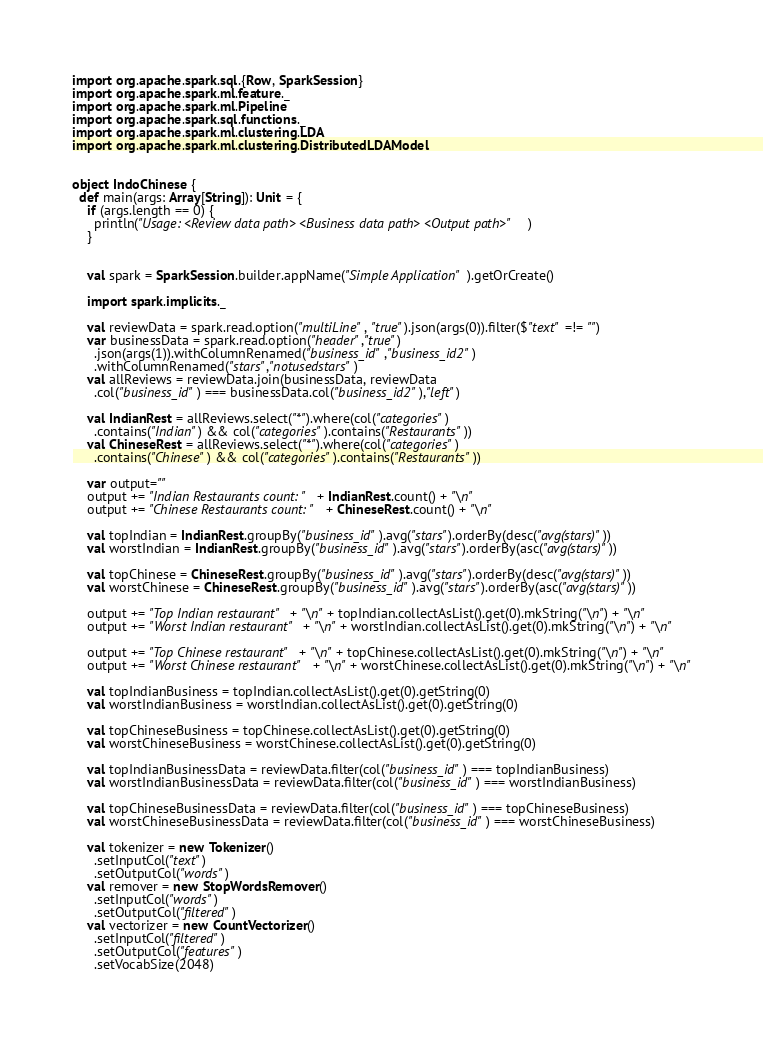Convert code to text. <code><loc_0><loc_0><loc_500><loc_500><_Scala_>import org.apache.spark.sql.{Row, SparkSession}
import org.apache.spark.ml.feature._
import org.apache.spark.ml.Pipeline
import org.apache.spark.sql.functions._
import org.apache.spark.ml.clustering.LDA
import org.apache.spark.ml.clustering.DistributedLDAModel


object IndoChinese {
  def main(args: Array[String]): Unit = {
    if (args.length == 0) {
      println("Usage: <Review data path> <Business data path> <Output path>")
    }


    val spark = SparkSession.builder.appName("Simple Application").getOrCreate()

    import spark.implicits._

    val reviewData = spark.read.option("multiLine", "true").json(args(0)).filter($"text" =!= "")
    var businessData = spark.read.option("header","true")
      .json(args(1)).withColumnRenamed("business_id","business_id2")
      .withColumnRenamed("stars","notusedstars")
    val allReviews = reviewData.join(businessData, reviewData
      .col("business_id") === businessData.col("business_id2"),"left")

    val IndianRest = allReviews.select("*").where(col("categories")
      .contains("Indian") && col("categories").contains("Restaurants"))
    val ChineseRest = allReviews.select("*").where(col("categories")
      .contains("Chinese") && col("categories").contains("Restaurants"))

    var output=""
    output += "Indian Restaurants count: " + IndianRest.count() + "\n"
    output += "Chinese Restaurants count: " + ChineseRest.count() + "\n"

    val topIndian = IndianRest.groupBy("business_id").avg("stars").orderBy(desc("avg(stars)"))
    val worstIndian = IndianRest.groupBy("business_id").avg("stars").orderBy(asc("avg(stars)"))

    val topChinese = ChineseRest.groupBy("business_id").avg("stars").orderBy(desc("avg(stars)"))
    val worstChinese = ChineseRest.groupBy("business_id").avg("stars").orderBy(asc("avg(stars)"))

    output += "Top Indian restaurant" + "\n" + topIndian.collectAsList().get(0).mkString("\n") + "\n"
    output += "Worst Indian restaurant" + "\n" + worstIndian.collectAsList().get(0).mkString("\n") + "\n"

    output += "Top Chinese restaurant" + "\n" + topChinese.collectAsList().get(0).mkString("\n") + "\n"
    output += "Worst Chinese restaurant" + "\n" + worstChinese.collectAsList().get(0).mkString("\n") + "\n"

    val topIndianBusiness = topIndian.collectAsList().get(0).getString(0)
    val worstIndianBusiness = worstIndian.collectAsList().get(0).getString(0)

    val topChineseBusiness = topChinese.collectAsList().get(0).getString(0)
    val worstChineseBusiness = worstChinese.collectAsList().get(0).getString(0)

    val topIndianBusinessData = reviewData.filter(col("business_id") === topIndianBusiness)
    val worstIndianBusinessData = reviewData.filter(col("business_id") === worstIndianBusiness)

    val topChineseBusinessData = reviewData.filter(col("business_id") === topChineseBusiness)
    val worstChineseBusinessData = reviewData.filter(col("business_id") === worstChineseBusiness)

    val tokenizer = new Tokenizer()
      .setInputCol("text")
      .setOutputCol("words")
    val remover = new StopWordsRemover()
      .setInputCol("words")
      .setOutputCol("filtered")
    val vectorizer = new CountVectorizer()
      .setInputCol("filtered")
      .setOutputCol("features")
      .setVocabSize(2048)</code> 